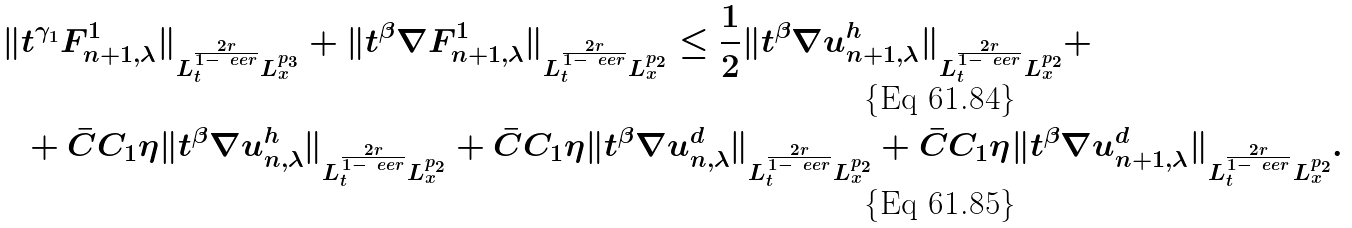Convert formula to latex. <formula><loc_0><loc_0><loc_500><loc_500>\| & t ^ { \gamma _ { 1 } } F ^ { 1 } _ { n + 1 , \lambda } \| _ { L ^ { \frac { 2 r } { 1 - \ e e r } } _ { t } L ^ { p _ { 3 } } _ { x } } + \| t ^ { \beta } \nabla F ^ { 1 } _ { n + 1 , \lambda } \| _ { L ^ { \frac { 2 r } { 1 - \ e e r } } _ { t } L ^ { p _ { 2 } } _ { x } } \leq \frac { 1 } { 2 } \| t ^ { \beta } \nabla u ^ { h } _ { n + 1 , \lambda } \| _ { L ^ { \frac { 2 r } { 1 - \ e e r } } _ { t } L ^ { p _ { 2 } } _ { x } } + \\ & + \bar { C } C _ { 1 } \eta \| t ^ { \beta } \nabla u ^ { h } _ { n , \lambda } \| _ { L ^ { \frac { 2 r } { 1 - \ e e r } } _ { t } L ^ { p _ { 2 } } _ { x } } + \bar { C } C _ { 1 } \eta \| t ^ { \beta } \nabla u ^ { d } _ { n , \lambda } \| _ { L ^ { \frac { 2 r } { 1 - \ e e r } } _ { t } L ^ { p _ { 2 } } _ { x } } + \bar { C } C _ { 1 } \eta \| t ^ { \beta } \nabla u ^ { d } _ { n + 1 , \lambda } \| _ { L ^ { \frac { 2 r } { 1 - \ e e r } } _ { t } L ^ { p _ { 2 } } _ { x } } .</formula> 